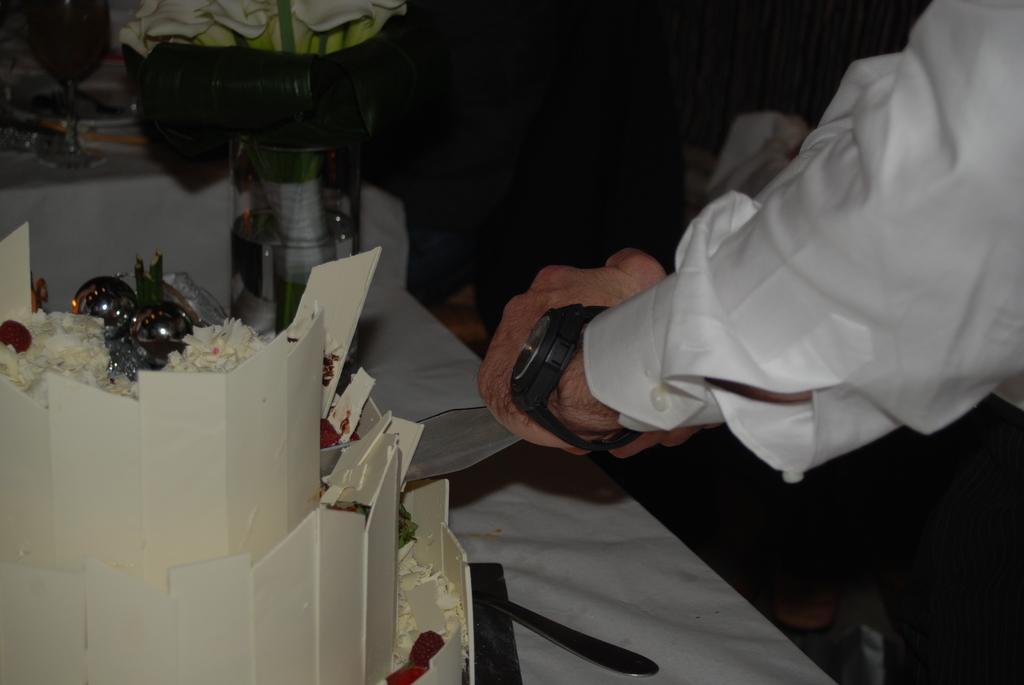Can you describe this image briefly? In this image in front we can see the hand of a person. There is a table. On top of it there is a cake and a few other objects. 